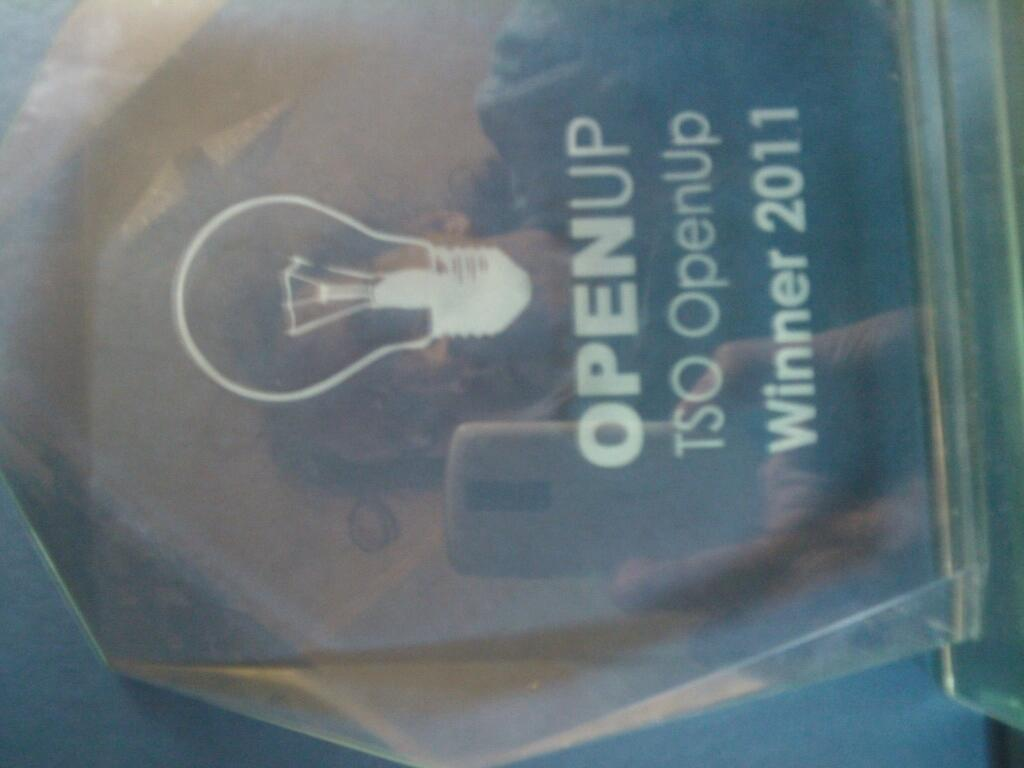What is the main subject of the image? The main subject of the image is an award. What can be seen on the surface of the award? The award has a reflection of a woman holding a cellphone on it. What type of record can be seen on the award in the image? There is no record present on the award in the image. What is the texture of the jar in the image? There is no jar present in the image. 